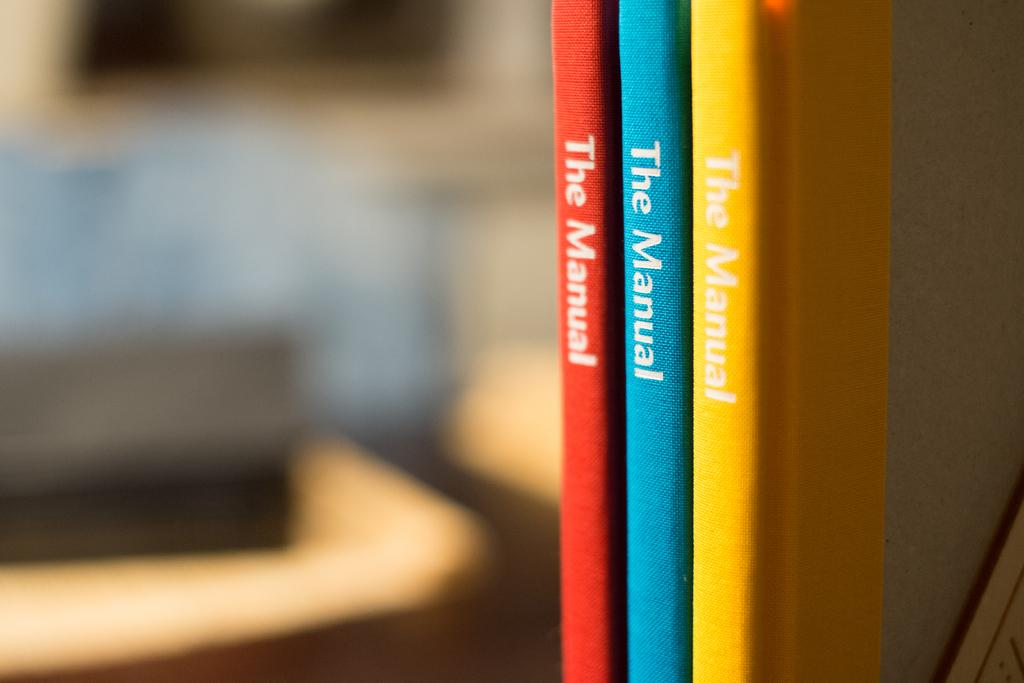<image>
Share a concise interpretation of the image provided. Three thin books are titled The Manual and one is red, one is blue and one is yellow in color. 